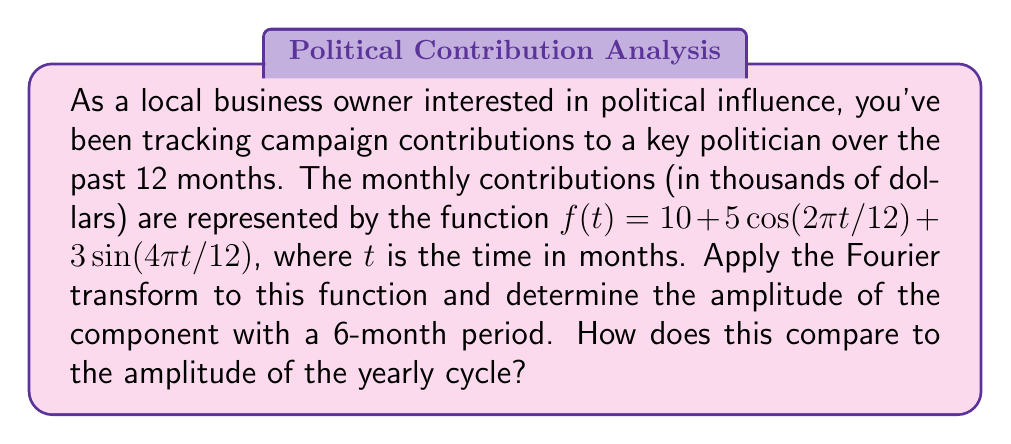Could you help me with this problem? To solve this problem, we'll follow these steps:

1) First, let's identify the components of the given function:
   $f(t) = 10 + 5\cos(2\pi t/12) + 3\sin(4\pi t/12)$

   - 10 is the constant term (DC component)
   - $5\cos(2\pi t/12)$ has a period of 12 months (yearly cycle)
   - $3\sin(4\pi t/12)$ has a period of 6 months

2) The Fourier transform of a cosine function $A\cos(\omega t)$ is:
   $$\mathcal{F}\{A\cos(\omega t)\} = \pi A[\delta(\omega - \omega_0) + \delta(\omega + \omega_0)]$$
   where $\omega_0$ is the angular frequency.

3) The Fourier transform of a sine function $B\sin(\omega t)$ is:
   $$\mathcal{F}\{B\sin(\omega t)\} = -j\pi B[\delta(\omega - \omega_0) - \delta(\omega + \omega_0)]$$

4) For the yearly cycle:
   $\omega_1 = 2\pi/12 = \pi/6$
   Amplitude = 5

5) For the 6-month cycle:
   $\omega_2 = 4\pi/12 = \pi/3$
   Amplitude = 3

6) The amplitude of the 6-month cycle (3) is smaller than the amplitude of the yearly cycle (5).

7) To compare, we can calculate the ratio:
   $\frac{\text{Amplitude of 6-month cycle}}{\text{Amplitude of yearly cycle}} = \frac{3}{5} = 0.6$
Answer: The amplitude of the component with a 6-month period is 3, which is 0.6 times the amplitude of the yearly cycle (5). 